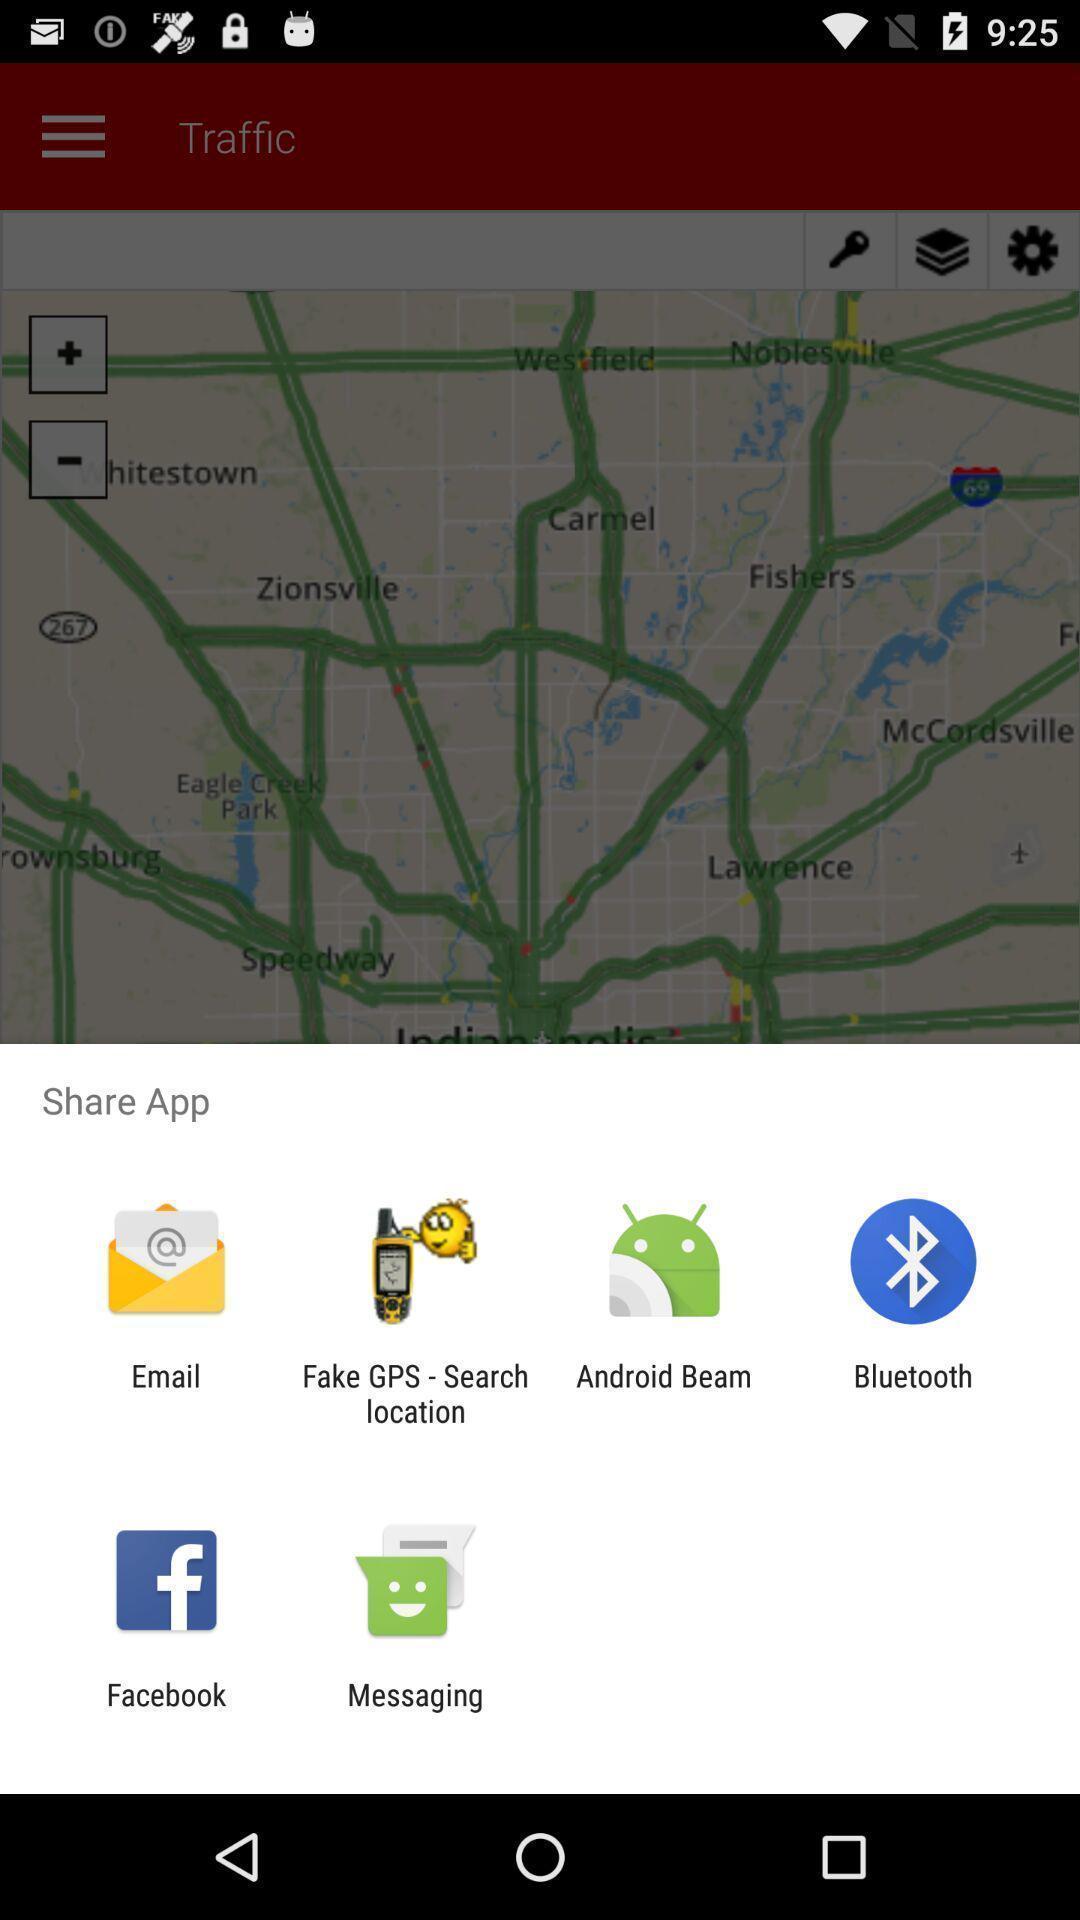Explain the elements present in this screenshot. Pop-up shows share app option with multiple apps. 